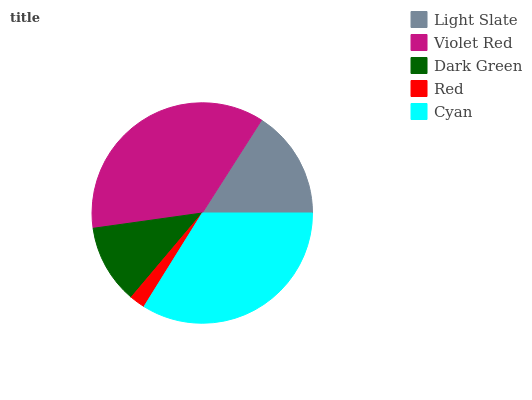Is Red the minimum?
Answer yes or no. Yes. Is Violet Red the maximum?
Answer yes or no. Yes. Is Dark Green the minimum?
Answer yes or no. No. Is Dark Green the maximum?
Answer yes or no. No. Is Violet Red greater than Dark Green?
Answer yes or no. Yes. Is Dark Green less than Violet Red?
Answer yes or no. Yes. Is Dark Green greater than Violet Red?
Answer yes or no. No. Is Violet Red less than Dark Green?
Answer yes or no. No. Is Light Slate the high median?
Answer yes or no. Yes. Is Light Slate the low median?
Answer yes or no. Yes. Is Dark Green the high median?
Answer yes or no. No. Is Red the low median?
Answer yes or no. No. 